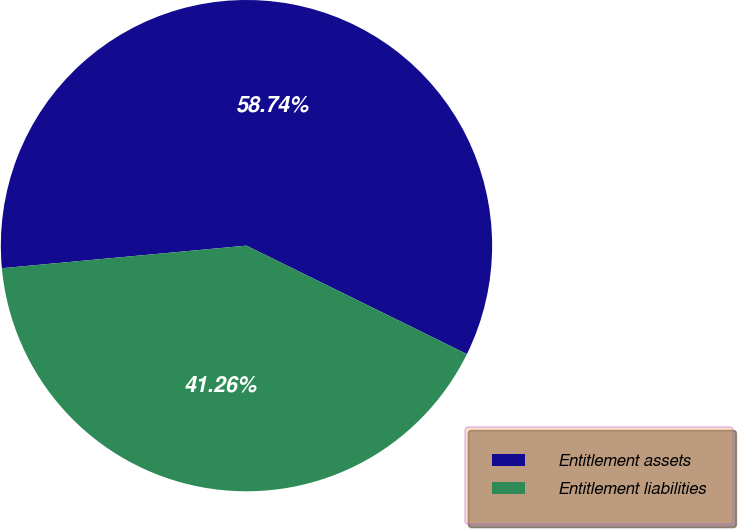Convert chart to OTSL. <chart><loc_0><loc_0><loc_500><loc_500><pie_chart><fcel>Entitlement assets<fcel>Entitlement liabilities<nl><fcel>58.74%<fcel>41.26%<nl></chart> 